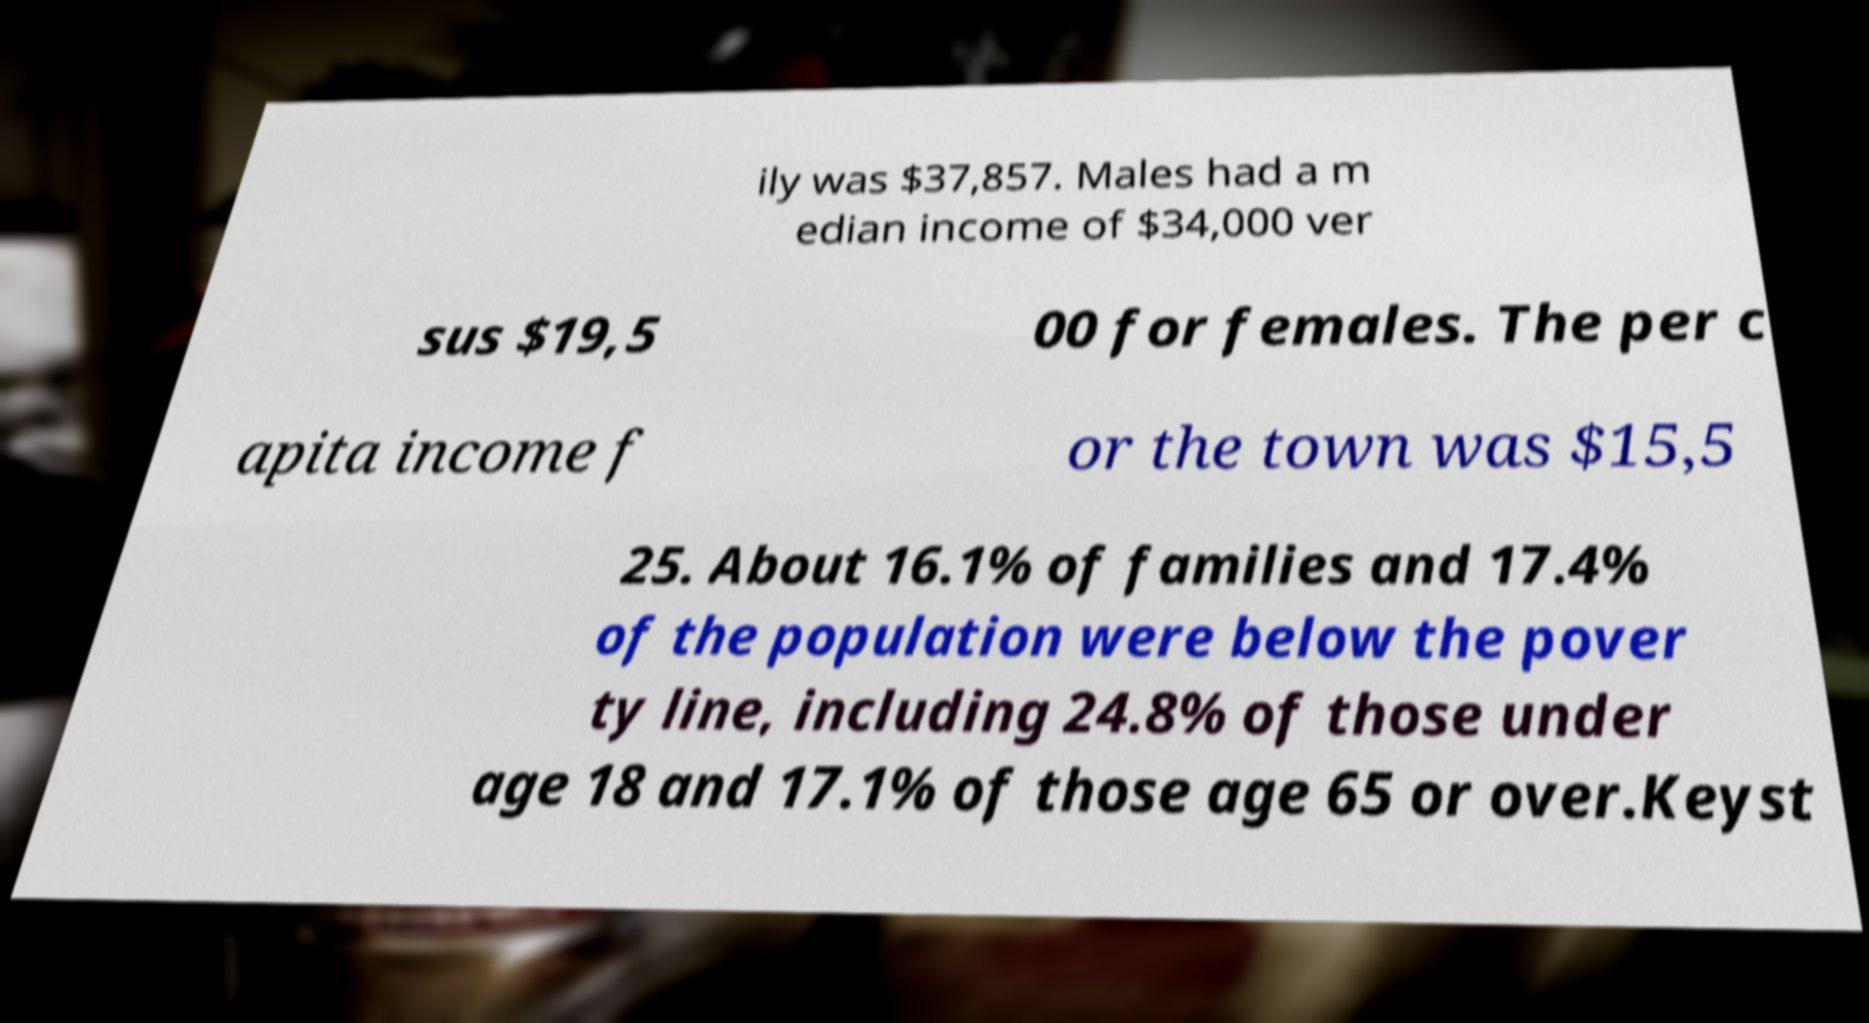Could you assist in decoding the text presented in this image and type it out clearly? ily was $37,857. Males had a m edian income of $34,000 ver sus $19,5 00 for females. The per c apita income f or the town was $15,5 25. About 16.1% of families and 17.4% of the population were below the pover ty line, including 24.8% of those under age 18 and 17.1% of those age 65 or over.Keyst 